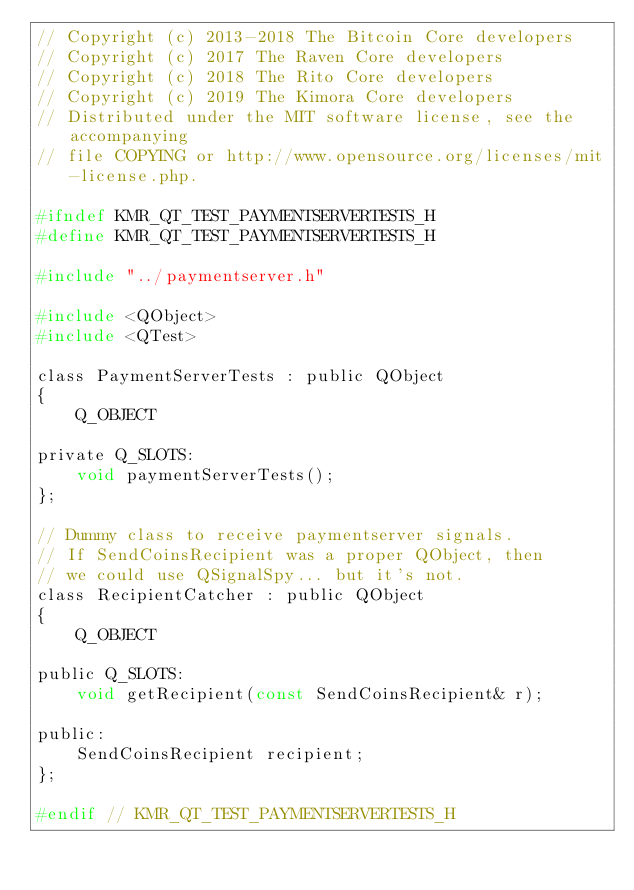<code> <loc_0><loc_0><loc_500><loc_500><_C_>// Copyright (c) 2013-2018 The Bitcoin Core developers
// Copyright (c) 2017 The Raven Core developers
// Copyright (c) 2018 The Rito Core developers
// Copyright (c) 2019 The Kimora Core developers
// Distributed under the MIT software license, see the accompanying
// file COPYING or http://www.opensource.org/licenses/mit-license.php.

#ifndef KMR_QT_TEST_PAYMENTSERVERTESTS_H
#define KMR_QT_TEST_PAYMENTSERVERTESTS_H

#include "../paymentserver.h"

#include <QObject>
#include <QTest>

class PaymentServerTests : public QObject
{
    Q_OBJECT

private Q_SLOTS:
    void paymentServerTests();
};

// Dummy class to receive paymentserver signals.
// If SendCoinsRecipient was a proper QObject, then
// we could use QSignalSpy... but it's not.
class RecipientCatcher : public QObject
{
    Q_OBJECT

public Q_SLOTS:
    void getRecipient(const SendCoinsRecipient& r);

public:
    SendCoinsRecipient recipient;
};

#endif // KMR_QT_TEST_PAYMENTSERVERTESTS_H
</code> 